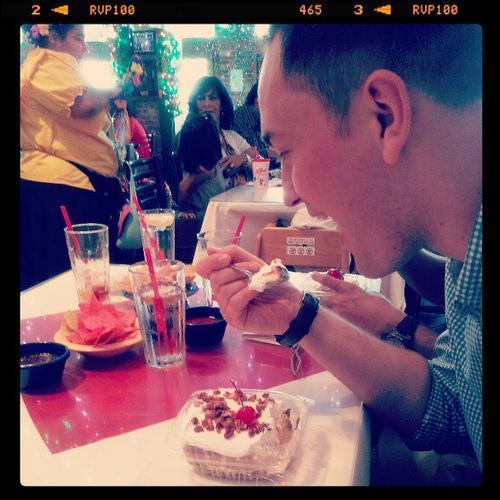How many glasses are on the table?
Give a very brief answer. 4. 